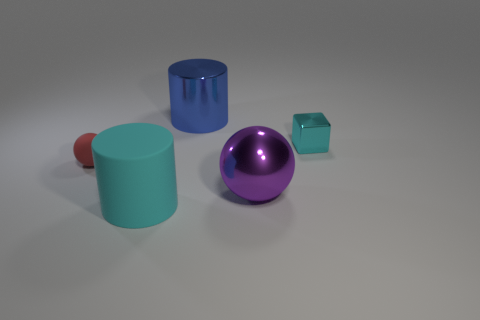Add 3 tiny gray matte things. How many objects exist? 8 Subtract all cylinders. How many objects are left? 3 Subtract all cyan things. Subtract all big green shiny cylinders. How many objects are left? 3 Add 4 cubes. How many cubes are left? 5 Add 2 metal cubes. How many metal cubes exist? 3 Subtract 0 yellow cubes. How many objects are left? 5 